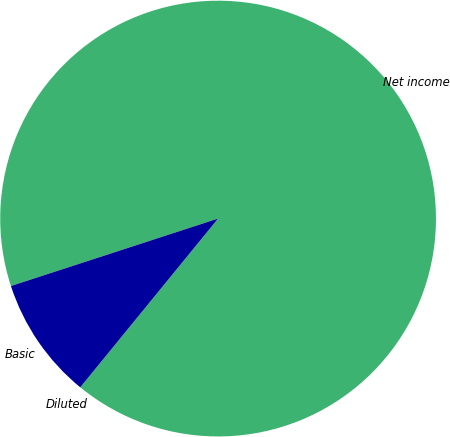<chart> <loc_0><loc_0><loc_500><loc_500><pie_chart><fcel>Net income<fcel>Basic<fcel>Diluted<nl><fcel>90.91%<fcel>9.09%<fcel>0.0%<nl></chart> 